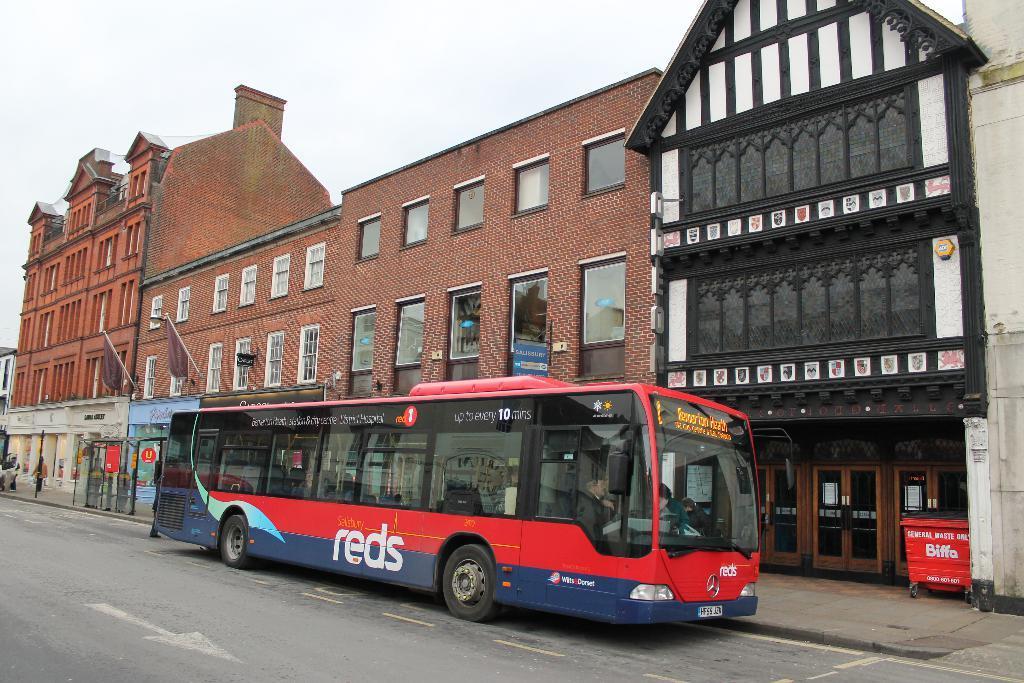Can you describe this image briefly? In this picture I can see the buildings. At the bottom there is a man who is riding a bus. On the right I can see the doors and dustbin. At the top I can see the sky. 